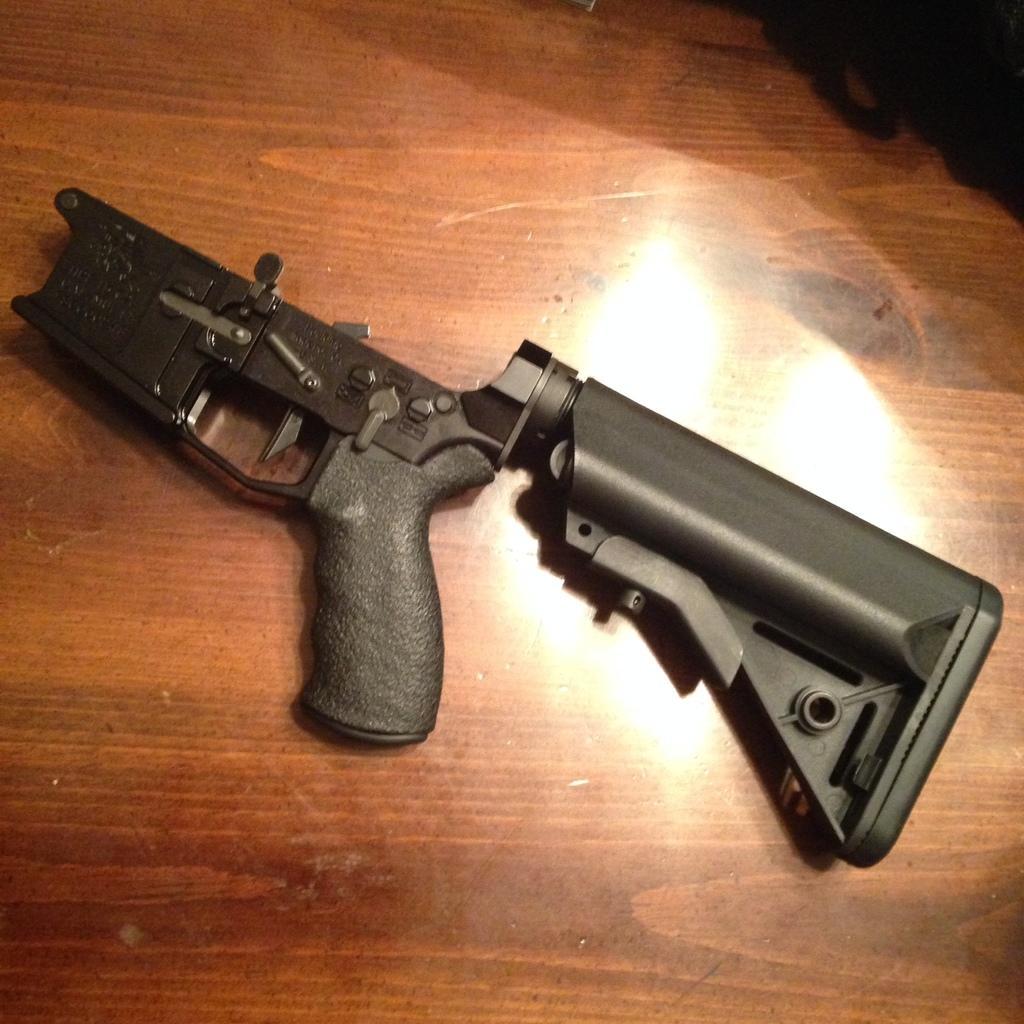Describe this image in one or two sentences. This image consists of a gun, which is in black color. It is placed on the table. 